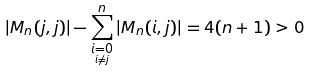<formula> <loc_0><loc_0><loc_500><loc_500>| M _ { n } ( j , j ) | - \sum _ { \underset { i \neq j } { i = 0 } } ^ { n } | M _ { n } ( i , j ) | = 4 ( n + 1 ) > 0</formula> 